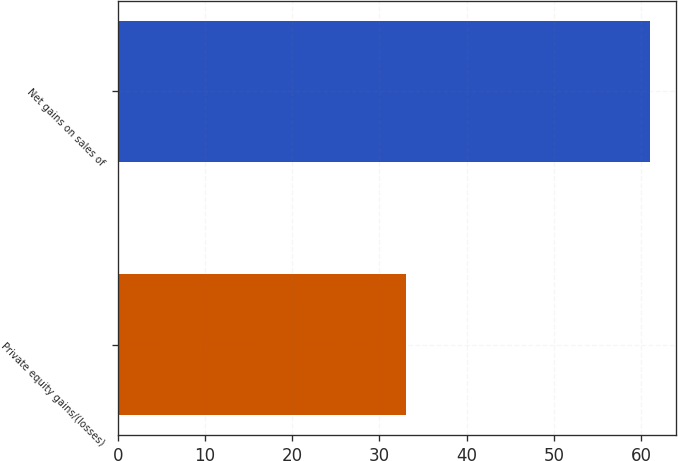<chart> <loc_0><loc_0><loc_500><loc_500><bar_chart><fcel>Private equity gains/(losses)<fcel>Net gains on sales of<nl><fcel>33<fcel>61<nl></chart> 